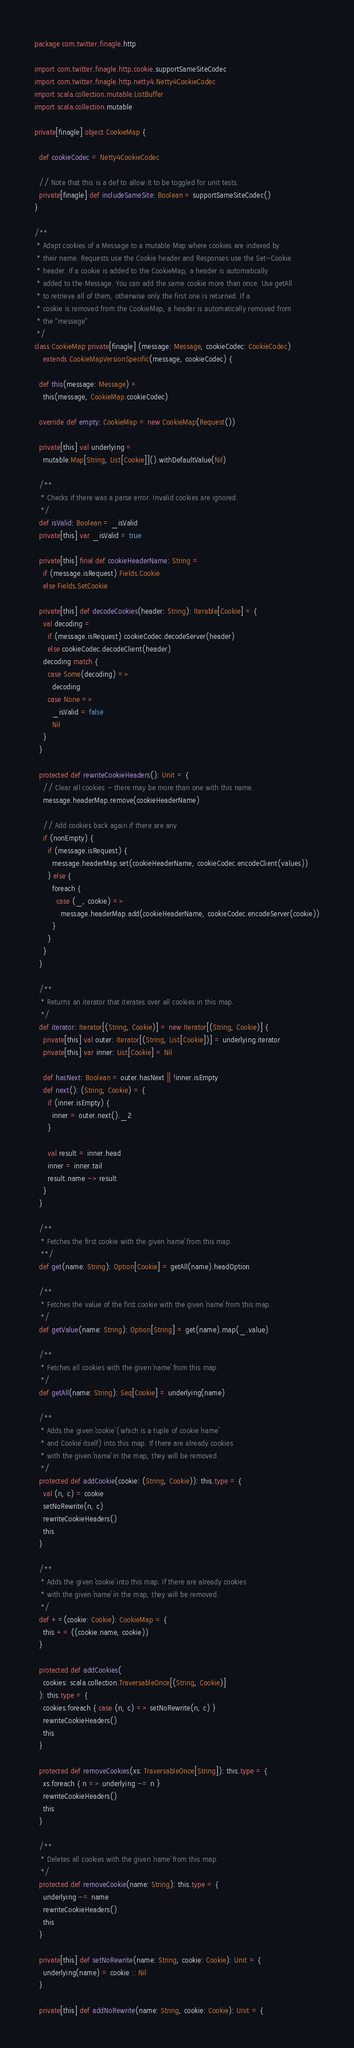<code> <loc_0><loc_0><loc_500><loc_500><_Scala_>package com.twitter.finagle.http

import com.twitter.finagle.http.cookie.supportSameSiteCodec
import com.twitter.finagle.http.netty4.Netty4CookieCodec
import scala.collection.mutable.ListBuffer
import scala.collection.mutable

private[finagle] object CookieMap {

  def cookieCodec = Netty4CookieCodec

  // Note that this is a def to allow it to be toggled for unit tests.
  private[finagle] def includeSameSite: Boolean = supportSameSiteCodec()
}

/**
 * Adapt cookies of a Message to a mutable Map where cookies are indexed by
 * their name. Requests use the Cookie header and Responses use the Set-Cookie
 * header. If a cookie is added to the CookieMap, a header is automatically
 * added to the Message. You can add the same cookie more than once. Use getAll
 * to retrieve all of them, otherwise only the first one is returned. If a
 * cookie is removed from the CookieMap, a header is automatically removed from
 * the ''message''
 */
class CookieMap private[finagle] (message: Message, cookieCodec: CookieCodec)
    extends CookieMapVersionSpecific(message, cookieCodec) {

  def this(message: Message) =
    this(message, CookieMap.cookieCodec)

  override def empty: CookieMap = new CookieMap(Request())

  private[this] val underlying =
    mutable.Map[String, List[Cookie]]().withDefaultValue(Nil)

  /**
   * Checks if there was a parse error. Invalid cookies are ignored.
   */
  def isValid: Boolean = _isValid
  private[this] var _isValid = true

  private[this] final def cookieHeaderName: String =
    if (message.isRequest) Fields.Cookie
    else Fields.SetCookie

  private[this] def decodeCookies(header: String): Iterable[Cookie] = {
    val decoding =
      if (message.isRequest) cookieCodec.decodeServer(header)
      else cookieCodec.decodeClient(header)
    decoding match {
      case Some(decoding) =>
        decoding
      case None =>
        _isValid = false
        Nil
    }
  }

  protected def rewriteCookieHeaders(): Unit = {
    // Clear all cookies - there may be more than one with this name.
    message.headerMap.remove(cookieHeaderName)

    // Add cookies back again if there are any
    if (nonEmpty) {
      if (message.isRequest) {
        message.headerMap.set(cookieHeaderName, cookieCodec.encodeClient(values))
      } else {
        foreach {
          case (_, cookie) =>
            message.headerMap.add(cookieHeaderName, cookieCodec.encodeServer(cookie))
        }
      }
    }
  }

  /**
   * Returns an iterator that iterates over all cookies in this map.
   */
  def iterator: Iterator[(String, Cookie)] = new Iterator[(String, Cookie)] {
    private[this] val outer: Iterator[(String, List[Cookie])] = underlying.iterator
    private[this] var inner: List[Cookie] = Nil

    def hasNext: Boolean = outer.hasNext || !inner.isEmpty
    def next(): (String, Cookie) = {
      if (inner.isEmpty) {
        inner = outer.next()._2
      }

      val result = inner.head
      inner = inner.tail
      result.name -> result
    }
  }

  /**
   * Fetches the first cookie with the given `name` from this map.
   **/
  def get(name: String): Option[Cookie] = getAll(name).headOption

  /**
   * Fetches the value of the first cookie with the given `name` from this map.
   */
  def getValue(name: String): Option[String] = get(name).map(_.value)

  /**
   * Fetches all cookies with the given `name` from this map.
   */
  def getAll(name: String): Seq[Cookie] = underlying(name)

  /**
   * Adds the given `cookie` (which is a tuple of cookie `name`
   * and Cookie` itself) into this map. If there are already cookies
   * with the given `name` in the map, they will be removed.
   */
  protected def addCookie(cookie: (String, Cookie)): this.type = {
    val (n, c) = cookie
    setNoRewrite(n, c)
    rewriteCookieHeaders()
    this
  }

  /**
   * Adds the given `cookie` into this map. If there are already cookies
   * with the given `name` in the map, they will be removed.
   */
  def +=(cookie: Cookie): CookieMap = {
    this += ((cookie.name, cookie))
  }

  protected def addCookies(
    cookies: scala.collection.TraversableOnce[(String, Cookie)]
  ): this.type = {
    cookies.foreach { case (n, c) => setNoRewrite(n, c) }
    rewriteCookieHeaders()
    this
  }

  protected def removeCookies(xs: TraversableOnce[String]): this.type = {
    xs.foreach { n => underlying -= n }
    rewriteCookieHeaders()
    this
  }

  /**
   * Deletes all cookies with the given `name` from this map.
   */
  protected def removeCookie(name: String): this.type = {
    underlying -= name
    rewriteCookieHeaders()
    this
  }

  private[this] def setNoRewrite(name: String, cookie: Cookie): Unit = {
    underlying(name) = cookie :: Nil
  }

  private[this] def addNoRewrite(name: String, cookie: Cookie): Unit = {</code> 